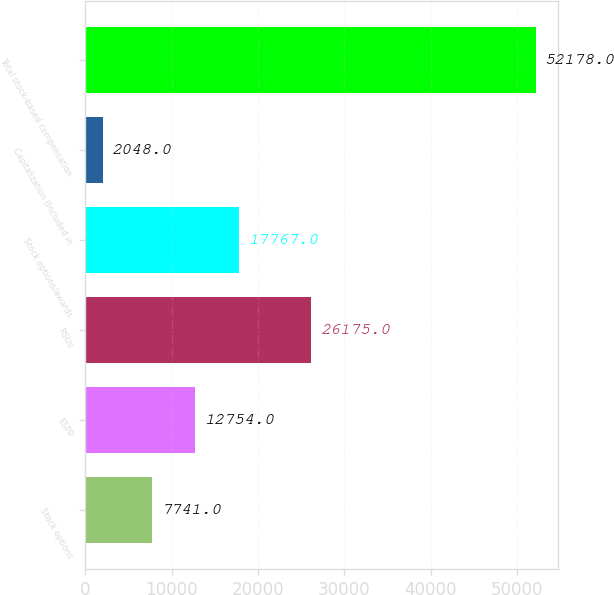Convert chart. <chart><loc_0><loc_0><loc_500><loc_500><bar_chart><fcel>Stock options<fcel>ESPP<fcel>RSUs<fcel>Stock options/awards<fcel>Capitalization (Included in<fcel>Total stock-based compensation<nl><fcel>7741<fcel>12754<fcel>26175<fcel>17767<fcel>2048<fcel>52178<nl></chart> 